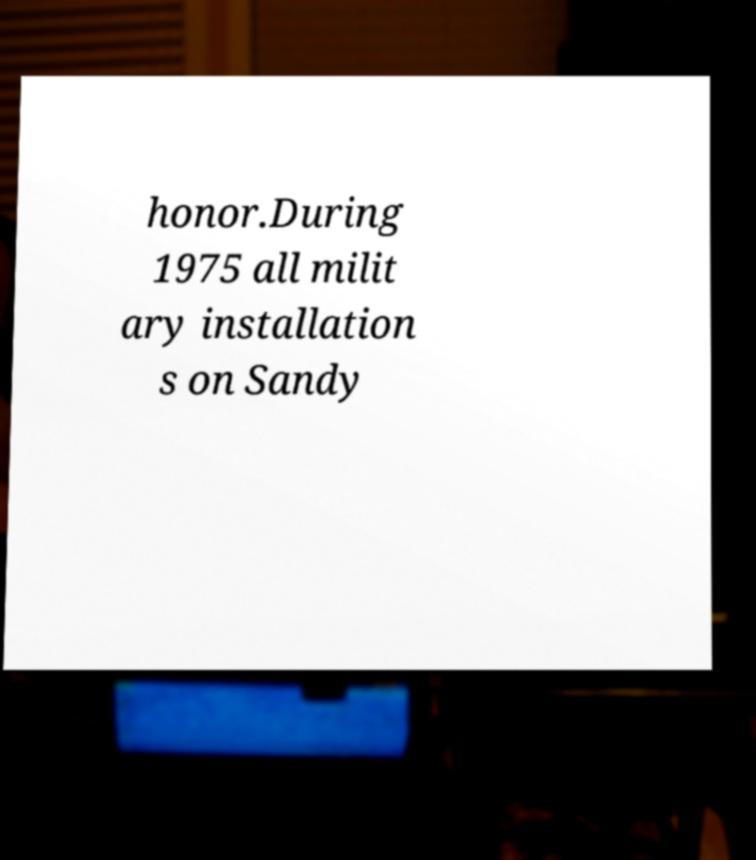What messages or text are displayed in this image? I need them in a readable, typed format. honor.During 1975 all milit ary installation s on Sandy 